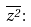<formula> <loc_0><loc_0><loc_500><loc_500>\overline { z ^ { 2 } } \colon</formula> 